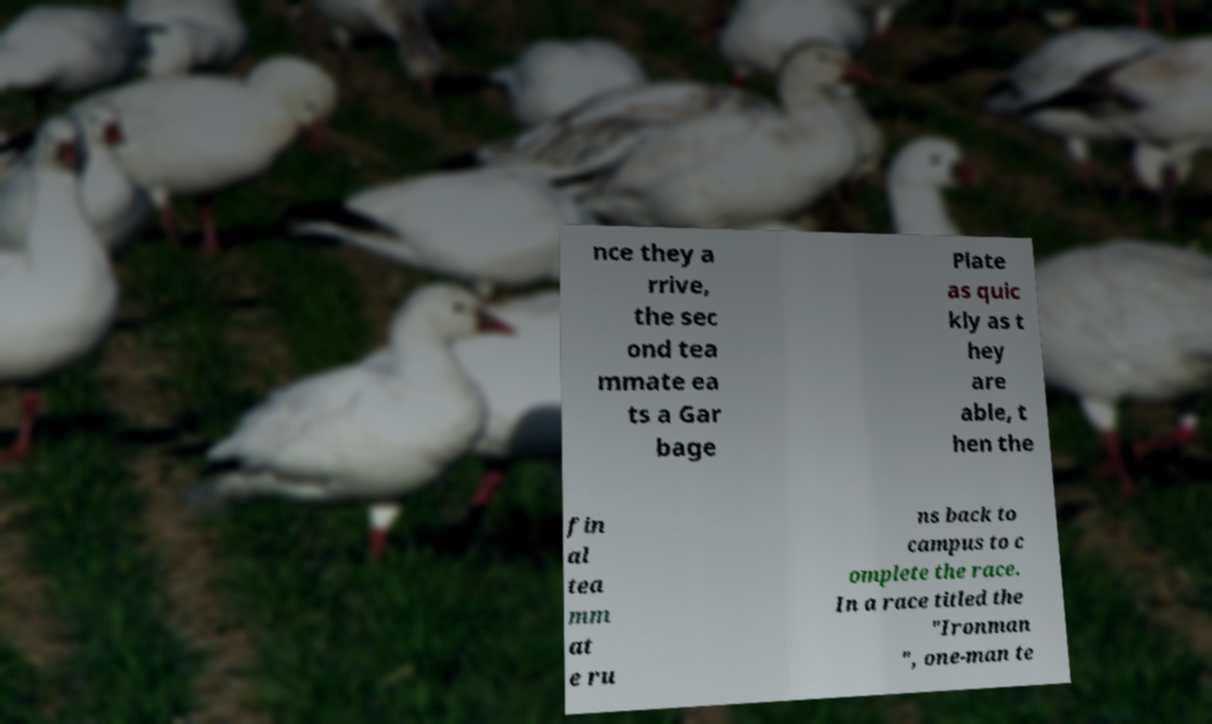Could you extract and type out the text from this image? nce they a rrive, the sec ond tea mmate ea ts a Gar bage Plate as quic kly as t hey are able, t hen the fin al tea mm at e ru ns back to campus to c omplete the race. In a race titled the "Ironman ", one-man te 